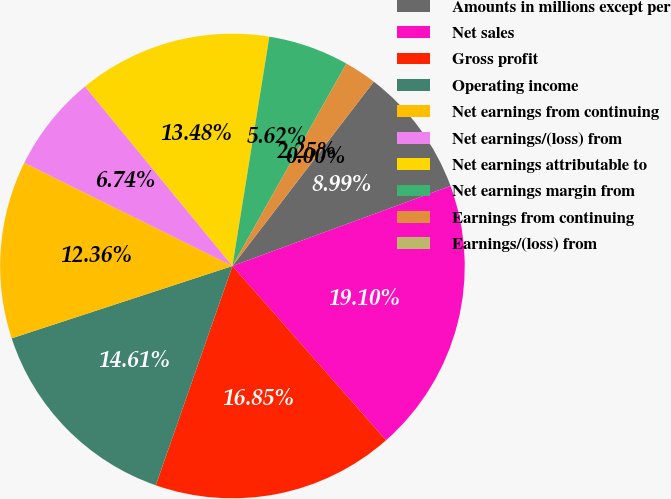Convert chart. <chart><loc_0><loc_0><loc_500><loc_500><pie_chart><fcel>Amounts in millions except per<fcel>Net sales<fcel>Gross profit<fcel>Operating income<fcel>Net earnings from continuing<fcel>Net earnings/(loss) from<fcel>Net earnings attributable to<fcel>Net earnings margin from<fcel>Earnings from continuing<fcel>Earnings/(loss) from<nl><fcel>8.99%<fcel>19.1%<fcel>16.85%<fcel>14.61%<fcel>12.36%<fcel>6.74%<fcel>13.48%<fcel>5.62%<fcel>2.25%<fcel>0.0%<nl></chart> 